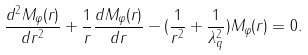<formula> <loc_0><loc_0><loc_500><loc_500>\frac { d ^ { 2 } M _ { \varphi } ( r ) } { d r ^ { 2 } } + \frac { 1 } { r } \frac { d M _ { \varphi } ( r ) } { d r } - ( \frac { 1 } { r ^ { 2 } } + \frac { 1 } { \lambda _ { q } ^ { 2 } } ) M _ { \varphi } ( r ) = 0 .</formula> 